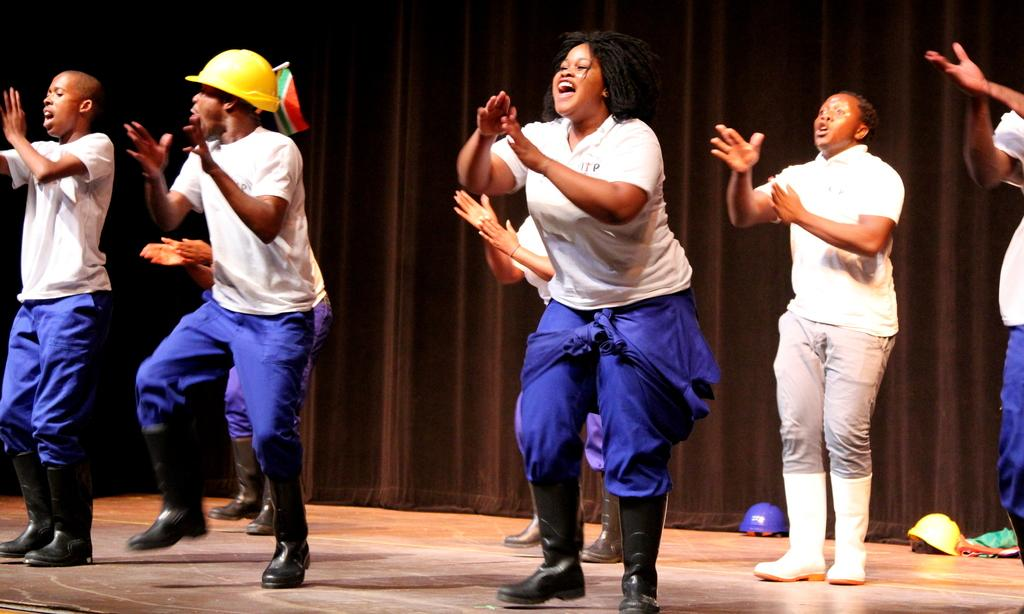What are the people in the image doing? The people in the image are dancing. Can you describe the man on the left side of the image? The man on the left side of the image is wearing a helmet. What can be seen in the background of the image? There is a curtain in the background of the image. What else can be seen at the bottom of the image? Helmets are visible at the bottom of the image. What type of lace is used to decorate the quarter in the image? There is no quarter or lace present in the image. How does love manifest itself in the image? The image does not depict love or any related emotions; it shows people dancing and wearing helmets. 